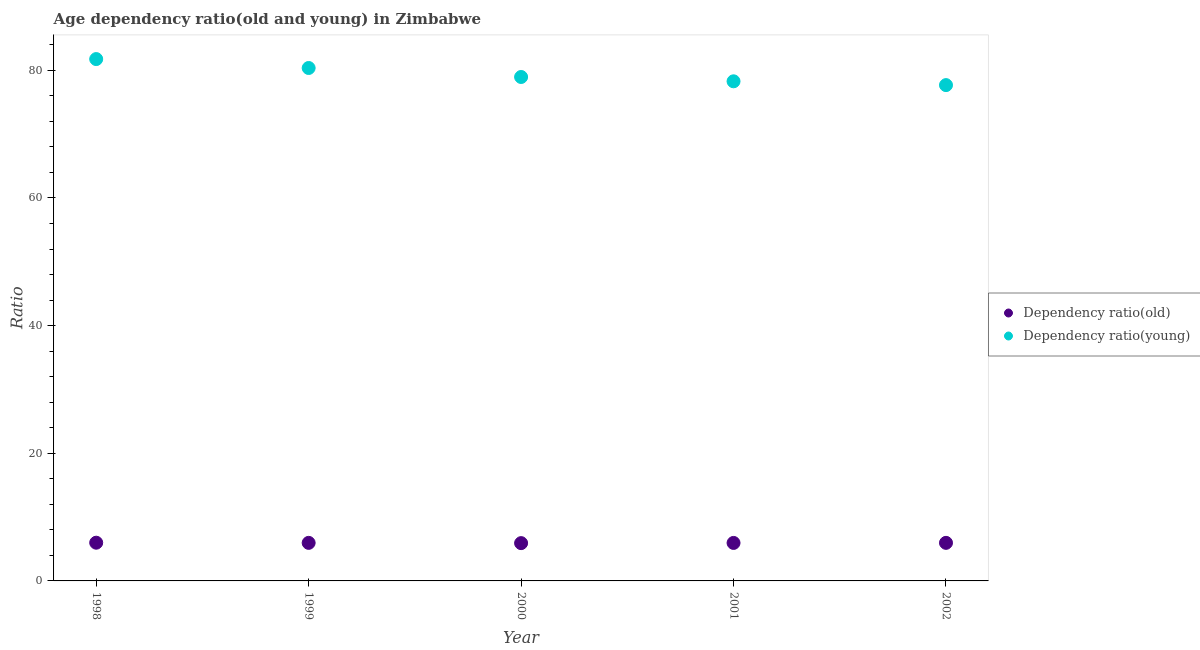How many different coloured dotlines are there?
Provide a short and direct response. 2. What is the age dependency ratio(old) in 1999?
Your response must be concise. 5.96. Across all years, what is the maximum age dependency ratio(young)?
Offer a very short reply. 81.76. Across all years, what is the minimum age dependency ratio(young)?
Make the answer very short. 77.68. In which year was the age dependency ratio(old) maximum?
Offer a terse response. 1998. In which year was the age dependency ratio(old) minimum?
Keep it short and to the point. 2000. What is the total age dependency ratio(old) in the graph?
Your response must be concise. 29.79. What is the difference between the age dependency ratio(old) in 1998 and that in 2002?
Give a very brief answer. 0.02. What is the difference between the age dependency ratio(old) in 2001 and the age dependency ratio(young) in 2000?
Offer a terse response. -73. What is the average age dependency ratio(young) per year?
Ensure brevity in your answer.  79.41. In the year 1999, what is the difference between the age dependency ratio(old) and age dependency ratio(young)?
Offer a very short reply. -74.4. In how many years, is the age dependency ratio(old) greater than 16?
Ensure brevity in your answer.  0. What is the ratio of the age dependency ratio(young) in 1999 to that in 2000?
Your answer should be very brief. 1.02. What is the difference between the highest and the second highest age dependency ratio(young)?
Give a very brief answer. 1.4. What is the difference between the highest and the lowest age dependency ratio(young)?
Provide a succinct answer. 4.08. How many years are there in the graph?
Provide a short and direct response. 5. Are the values on the major ticks of Y-axis written in scientific E-notation?
Offer a terse response. No. Where does the legend appear in the graph?
Your response must be concise. Center right. How many legend labels are there?
Ensure brevity in your answer.  2. What is the title of the graph?
Offer a terse response. Age dependency ratio(old and young) in Zimbabwe. Does "From human activities" appear as one of the legend labels in the graph?
Keep it short and to the point. No. What is the label or title of the Y-axis?
Offer a very short reply. Ratio. What is the Ratio in Dependency ratio(old) in 1998?
Offer a very short reply. 5.99. What is the Ratio of Dependency ratio(young) in 1998?
Provide a succinct answer. 81.76. What is the Ratio of Dependency ratio(old) in 1999?
Provide a short and direct response. 5.96. What is the Ratio of Dependency ratio(young) in 1999?
Offer a very short reply. 80.36. What is the Ratio in Dependency ratio(old) in 2000?
Keep it short and to the point. 5.92. What is the Ratio in Dependency ratio(young) in 2000?
Offer a very short reply. 78.96. What is the Ratio of Dependency ratio(old) in 2001?
Your answer should be very brief. 5.95. What is the Ratio in Dependency ratio(young) in 2001?
Offer a terse response. 78.28. What is the Ratio of Dependency ratio(old) in 2002?
Make the answer very short. 5.96. What is the Ratio in Dependency ratio(young) in 2002?
Your response must be concise. 77.68. Across all years, what is the maximum Ratio in Dependency ratio(old)?
Your response must be concise. 5.99. Across all years, what is the maximum Ratio of Dependency ratio(young)?
Give a very brief answer. 81.76. Across all years, what is the minimum Ratio in Dependency ratio(old)?
Your answer should be very brief. 5.92. Across all years, what is the minimum Ratio in Dependency ratio(young)?
Offer a terse response. 77.68. What is the total Ratio in Dependency ratio(old) in the graph?
Your answer should be very brief. 29.79. What is the total Ratio of Dependency ratio(young) in the graph?
Your answer should be compact. 397.05. What is the difference between the Ratio in Dependency ratio(old) in 1998 and that in 1999?
Offer a terse response. 0.03. What is the difference between the Ratio of Dependency ratio(young) in 1998 and that in 1999?
Keep it short and to the point. 1.4. What is the difference between the Ratio of Dependency ratio(old) in 1998 and that in 2000?
Make the answer very short. 0.07. What is the difference between the Ratio in Dependency ratio(young) in 1998 and that in 2000?
Offer a very short reply. 2.81. What is the difference between the Ratio of Dependency ratio(old) in 1998 and that in 2001?
Provide a short and direct response. 0.04. What is the difference between the Ratio of Dependency ratio(young) in 1998 and that in 2001?
Provide a short and direct response. 3.48. What is the difference between the Ratio in Dependency ratio(old) in 1998 and that in 2002?
Keep it short and to the point. 0.02. What is the difference between the Ratio of Dependency ratio(young) in 1998 and that in 2002?
Offer a terse response. 4.08. What is the difference between the Ratio in Dependency ratio(old) in 1999 and that in 2000?
Your answer should be very brief. 0.04. What is the difference between the Ratio of Dependency ratio(young) in 1999 and that in 2000?
Offer a very short reply. 1.41. What is the difference between the Ratio in Dependency ratio(old) in 1999 and that in 2001?
Offer a very short reply. 0.01. What is the difference between the Ratio in Dependency ratio(young) in 1999 and that in 2001?
Your answer should be very brief. 2.09. What is the difference between the Ratio of Dependency ratio(old) in 1999 and that in 2002?
Provide a short and direct response. -0. What is the difference between the Ratio in Dependency ratio(young) in 1999 and that in 2002?
Keep it short and to the point. 2.68. What is the difference between the Ratio in Dependency ratio(old) in 2000 and that in 2001?
Keep it short and to the point. -0.03. What is the difference between the Ratio in Dependency ratio(young) in 2000 and that in 2001?
Give a very brief answer. 0.68. What is the difference between the Ratio in Dependency ratio(old) in 2000 and that in 2002?
Offer a terse response. -0.04. What is the difference between the Ratio in Dependency ratio(young) in 2000 and that in 2002?
Ensure brevity in your answer.  1.27. What is the difference between the Ratio of Dependency ratio(old) in 2001 and that in 2002?
Offer a terse response. -0.01. What is the difference between the Ratio in Dependency ratio(young) in 2001 and that in 2002?
Provide a succinct answer. 0.6. What is the difference between the Ratio in Dependency ratio(old) in 1998 and the Ratio in Dependency ratio(young) in 1999?
Offer a terse response. -74.38. What is the difference between the Ratio of Dependency ratio(old) in 1998 and the Ratio of Dependency ratio(young) in 2000?
Offer a terse response. -72.97. What is the difference between the Ratio in Dependency ratio(old) in 1998 and the Ratio in Dependency ratio(young) in 2001?
Offer a very short reply. -72.29. What is the difference between the Ratio of Dependency ratio(old) in 1998 and the Ratio of Dependency ratio(young) in 2002?
Keep it short and to the point. -71.7. What is the difference between the Ratio of Dependency ratio(old) in 1999 and the Ratio of Dependency ratio(young) in 2000?
Your answer should be very brief. -72.99. What is the difference between the Ratio in Dependency ratio(old) in 1999 and the Ratio in Dependency ratio(young) in 2001?
Keep it short and to the point. -72.32. What is the difference between the Ratio of Dependency ratio(old) in 1999 and the Ratio of Dependency ratio(young) in 2002?
Provide a succinct answer. -71.72. What is the difference between the Ratio of Dependency ratio(old) in 2000 and the Ratio of Dependency ratio(young) in 2001?
Offer a very short reply. -72.36. What is the difference between the Ratio in Dependency ratio(old) in 2000 and the Ratio in Dependency ratio(young) in 2002?
Provide a succinct answer. -71.76. What is the difference between the Ratio of Dependency ratio(old) in 2001 and the Ratio of Dependency ratio(young) in 2002?
Give a very brief answer. -71.73. What is the average Ratio in Dependency ratio(old) per year?
Your answer should be compact. 5.96. What is the average Ratio of Dependency ratio(young) per year?
Your answer should be compact. 79.41. In the year 1998, what is the difference between the Ratio in Dependency ratio(old) and Ratio in Dependency ratio(young)?
Provide a succinct answer. -75.77. In the year 1999, what is the difference between the Ratio in Dependency ratio(old) and Ratio in Dependency ratio(young)?
Keep it short and to the point. -74.4. In the year 2000, what is the difference between the Ratio of Dependency ratio(old) and Ratio of Dependency ratio(young)?
Keep it short and to the point. -73.03. In the year 2001, what is the difference between the Ratio of Dependency ratio(old) and Ratio of Dependency ratio(young)?
Offer a terse response. -72.33. In the year 2002, what is the difference between the Ratio in Dependency ratio(old) and Ratio in Dependency ratio(young)?
Keep it short and to the point. -71.72. What is the ratio of the Ratio in Dependency ratio(young) in 1998 to that in 1999?
Provide a succinct answer. 1.02. What is the ratio of the Ratio in Dependency ratio(old) in 1998 to that in 2000?
Provide a succinct answer. 1.01. What is the ratio of the Ratio of Dependency ratio(young) in 1998 to that in 2000?
Provide a short and direct response. 1.04. What is the ratio of the Ratio in Dependency ratio(old) in 1998 to that in 2001?
Your response must be concise. 1.01. What is the ratio of the Ratio in Dependency ratio(young) in 1998 to that in 2001?
Your response must be concise. 1.04. What is the ratio of the Ratio in Dependency ratio(young) in 1998 to that in 2002?
Offer a terse response. 1.05. What is the ratio of the Ratio in Dependency ratio(young) in 1999 to that in 2000?
Your response must be concise. 1.02. What is the ratio of the Ratio of Dependency ratio(old) in 1999 to that in 2001?
Your response must be concise. 1. What is the ratio of the Ratio of Dependency ratio(young) in 1999 to that in 2001?
Make the answer very short. 1.03. What is the ratio of the Ratio in Dependency ratio(old) in 1999 to that in 2002?
Your answer should be very brief. 1. What is the ratio of the Ratio of Dependency ratio(young) in 1999 to that in 2002?
Make the answer very short. 1.03. What is the ratio of the Ratio in Dependency ratio(young) in 2000 to that in 2001?
Give a very brief answer. 1.01. What is the ratio of the Ratio of Dependency ratio(old) in 2000 to that in 2002?
Your answer should be very brief. 0.99. What is the ratio of the Ratio of Dependency ratio(young) in 2000 to that in 2002?
Your answer should be very brief. 1.02. What is the ratio of the Ratio of Dependency ratio(young) in 2001 to that in 2002?
Provide a succinct answer. 1.01. What is the difference between the highest and the second highest Ratio of Dependency ratio(old)?
Ensure brevity in your answer.  0.02. What is the difference between the highest and the second highest Ratio of Dependency ratio(young)?
Make the answer very short. 1.4. What is the difference between the highest and the lowest Ratio of Dependency ratio(old)?
Provide a short and direct response. 0.07. What is the difference between the highest and the lowest Ratio in Dependency ratio(young)?
Ensure brevity in your answer.  4.08. 